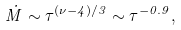Convert formula to latex. <formula><loc_0><loc_0><loc_500><loc_500>\dot { M } \sim \tau ^ { ( \nu - 4 ) / 3 } \sim \tau ^ { - 0 . 9 } ,</formula> 